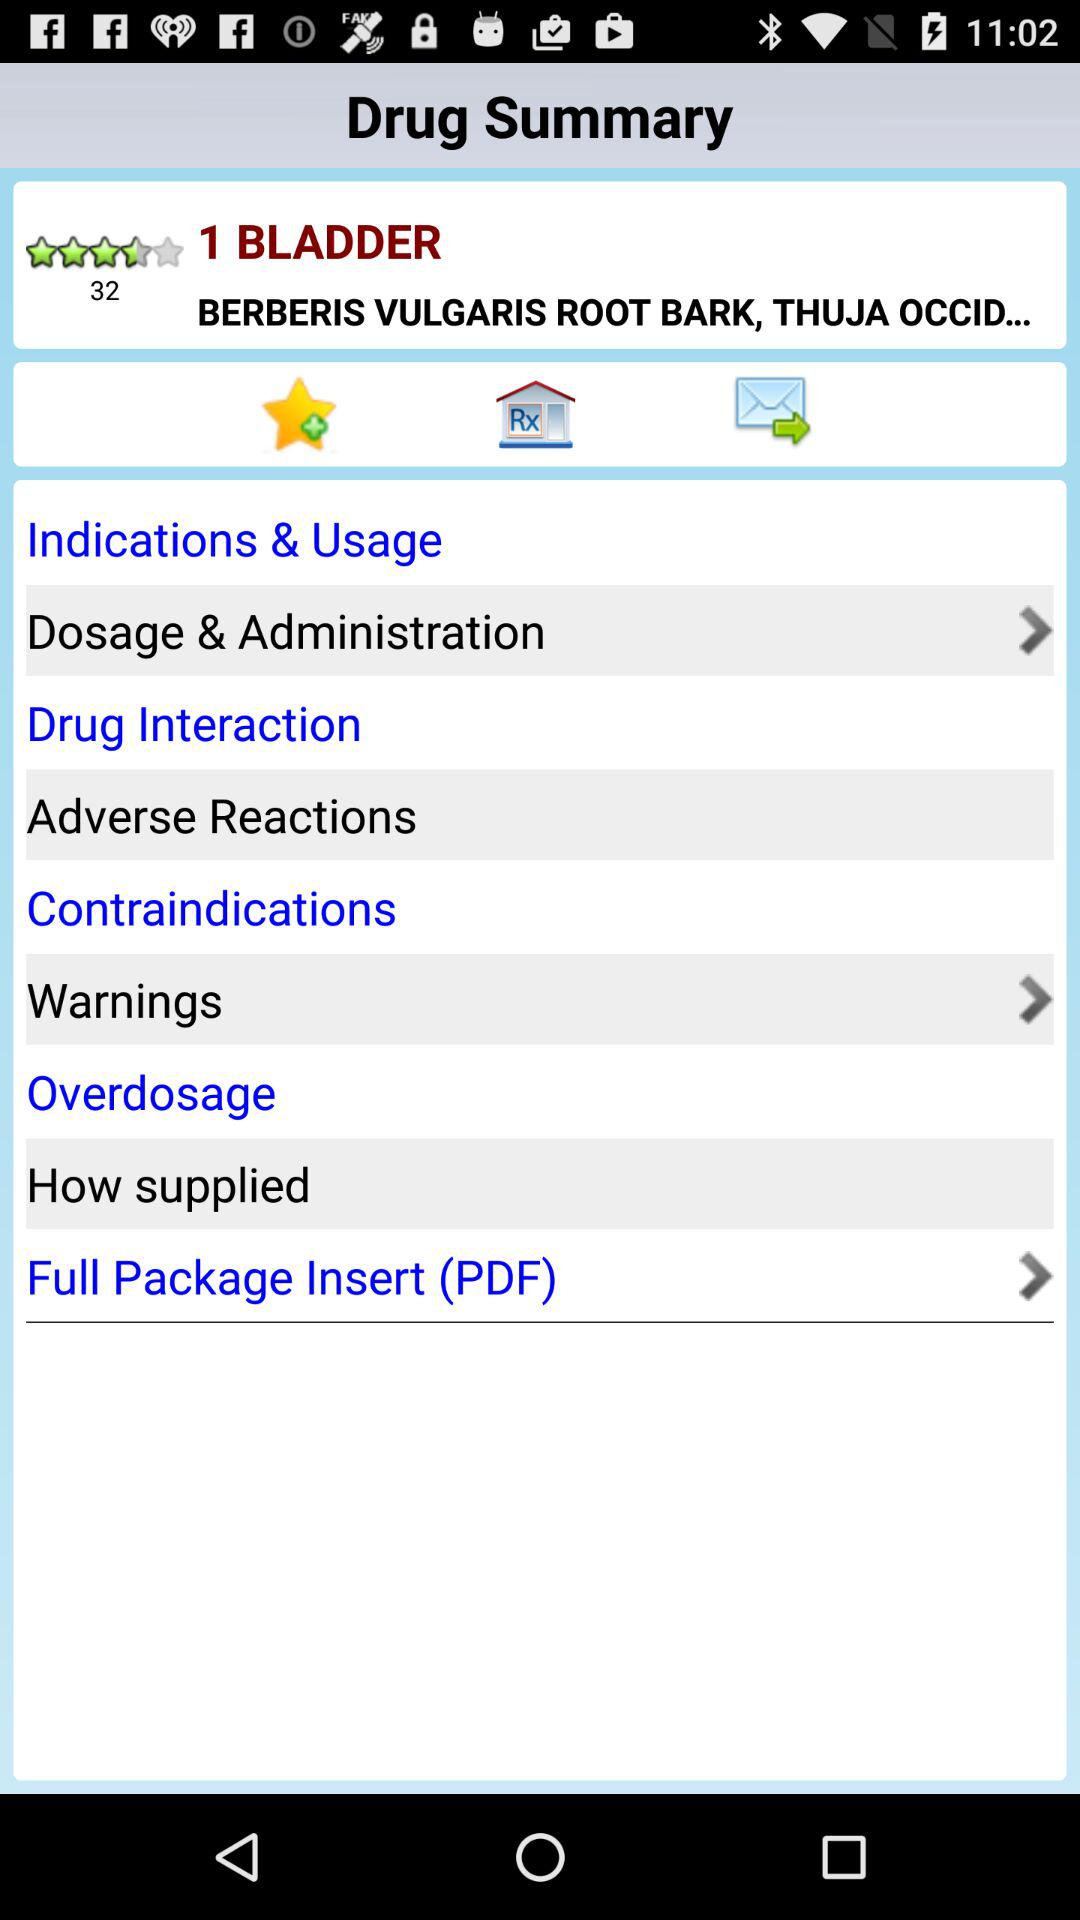What is the rating? The rating is 4.5 stars. 